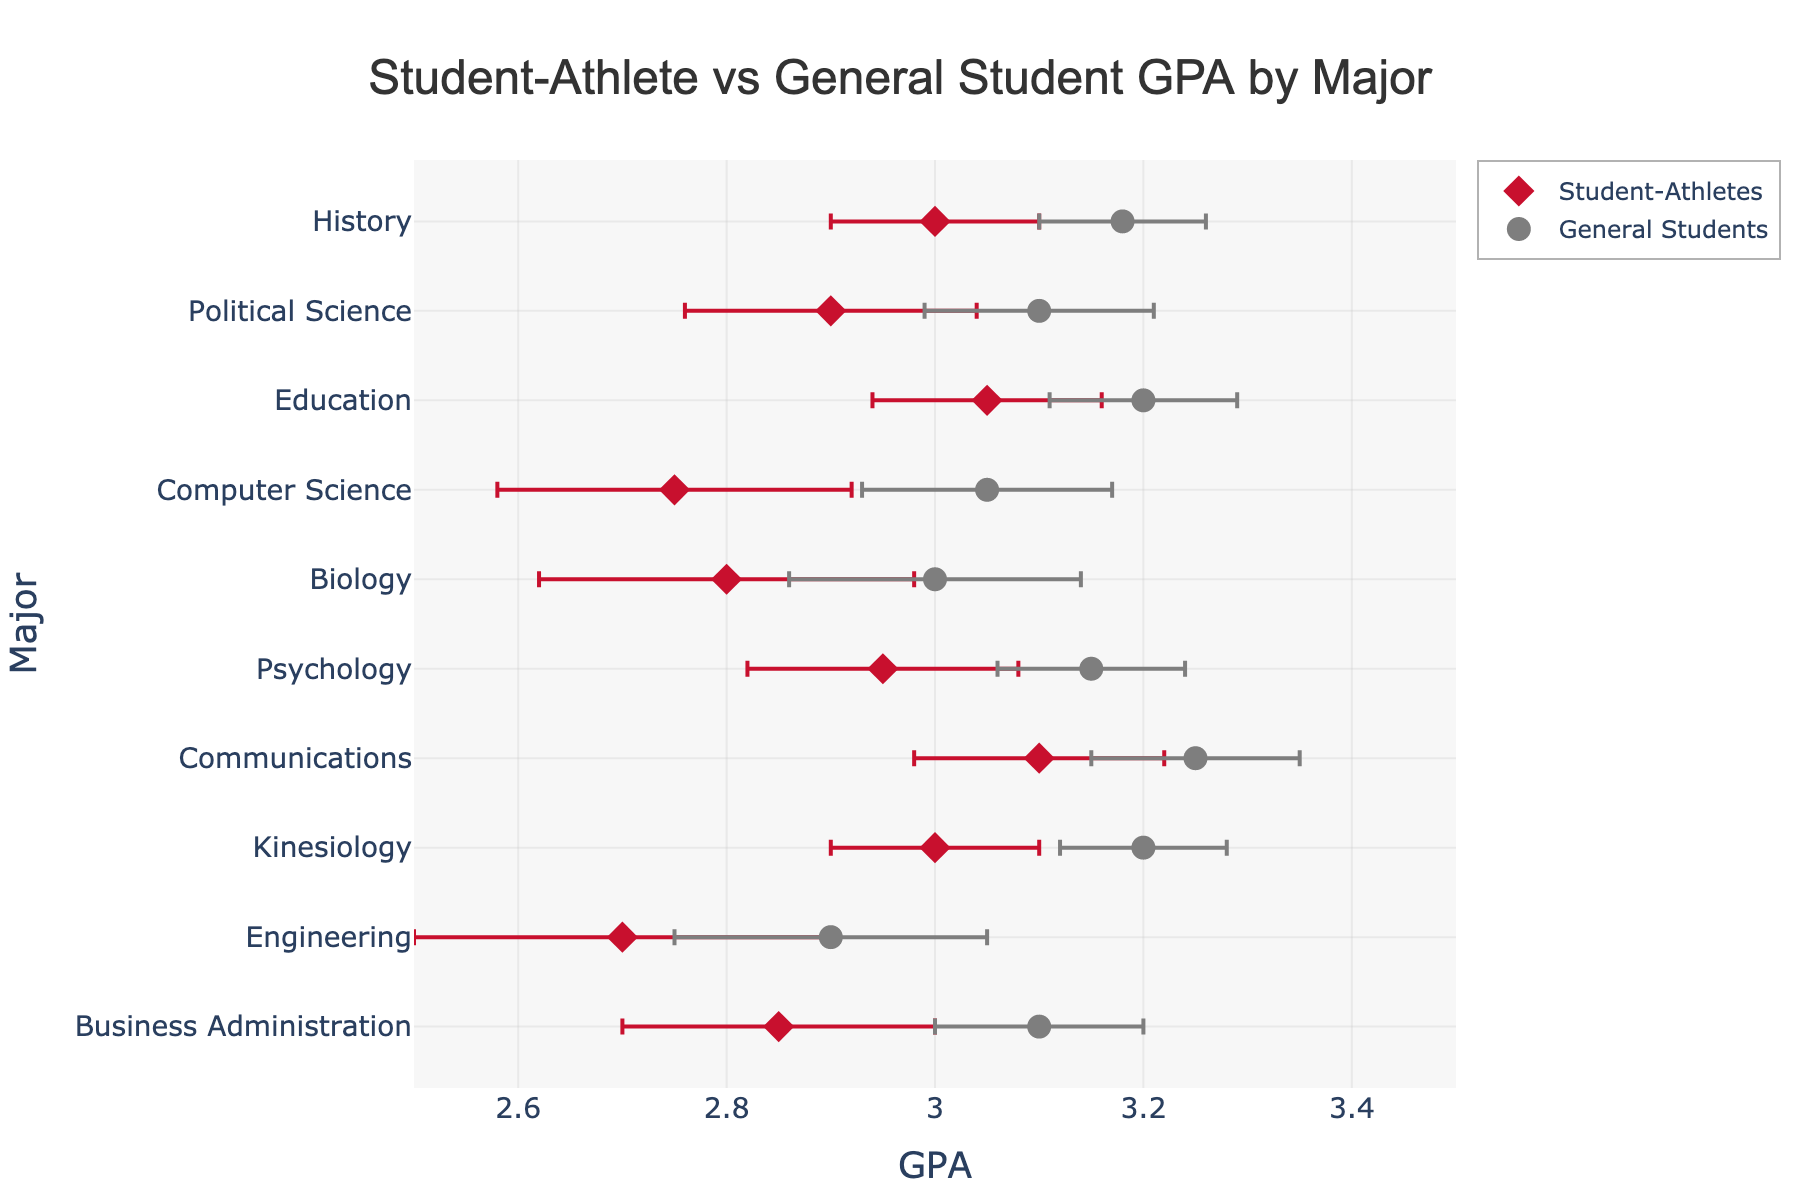What is the title of the figure? The title of the figure is displayed at the top center of the plot. It provides a brief summary of the data visualization.
Answer: Student-Athlete vs General Student GPA by Major Which group has the highest average GPA for Kinesiology? To find the group with the highest average GPA for Kinesiology, compare the dot positions corresponding to Kinesiology on the GPA axis for both student-athletes and general students. The general student group (3.20) is higher than the student-athlete group (3.00).
Answer: General Students What is the difference in GPA between student-athletes and general students in Business Administration? To determine the difference, subtract the student-athlete GPA from the general student GPA for Business Administration. That is 3.10 - 2.85.
Answer: 0.25 Which major shows the smallest difference in GPA between student-athletes and general students? Calculate the difference in GPA for each major by subtracting the student-athlete GPA from the general student GPA. The major with the smallest difference is identified by the smallest absolute value.
Answer: Communications What are the error bars for General Students in the Engineering major? The error bars for the General Students in the Engineering major can be found beside the marker in the Engineering row. They extend 0.15 units on both sides of the general student GPA (2.90).
Answer: 0.15 In which majors do student-athletes have a higher GPA than the general student population? Compare the GPA markers of student-athletes and general students for each major. Student-athletes have a higher GPA in majors where their markers are positioned to the right of the general students' markers.
Answer: None What is the average GPA of student-athletes across all majors? Sum the GPAs of student-athletes across all majors and divide by the number of majors: (2.85 + 2.70 + 3.00 + 3.10 + 2.95 + 2.80 + 2.75 + 3.05 + 2.90 + 3.00) / 10.
Answer: 2.91 How does the GPA of student-athletes in Political Science compare to their GPA in Biology? Compare the GPA markers for student-athletes in Political Science (2.90) and Biology (2.80). Student-athletes have a higher GPA in Political Science by 0.10 points.
Answer: 0.10 Which major has the highest standard deviation (error bar length) for student-athletes? Identify the major with the longest error bars for student-athletes by comparing the error values. The major with the highest value is Engineering (0.20).
Answer: Engineering Are there any majors where the GPA of student-athletes and general students are the same when considering error bars? If the GPA difference between student-athletes and general students falls within the range of their error bars, they can be considered about the same. This involves checking overlapping error bars for both groups across each major.
Answer: No 